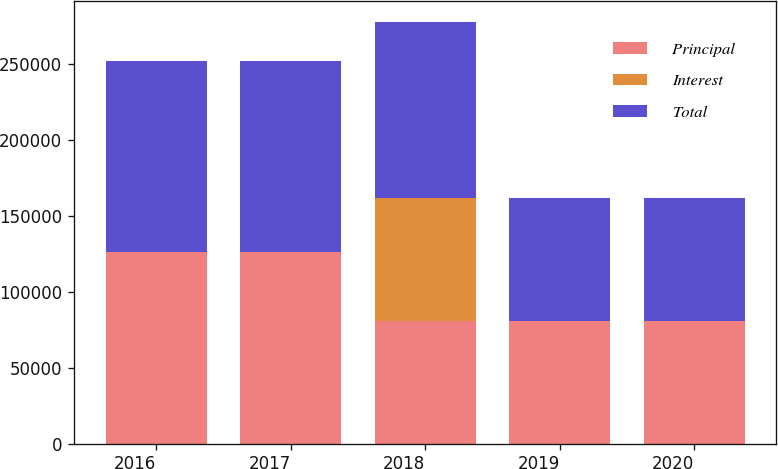Convert chart to OTSL. <chart><loc_0><loc_0><loc_500><loc_500><stacked_bar_chart><ecel><fcel>2016<fcel>2017<fcel>2018<fcel>2019<fcel>2020<nl><fcel>Principal<fcel>125878<fcel>125878<fcel>80740<fcel>80740<fcel>80740<nl><fcel>Interest<fcel>130<fcel>138<fcel>80740<fcel>23<fcel>25<nl><fcel>Total<fcel>125748<fcel>125740<fcel>116194<fcel>80717<fcel>80715<nl></chart> 